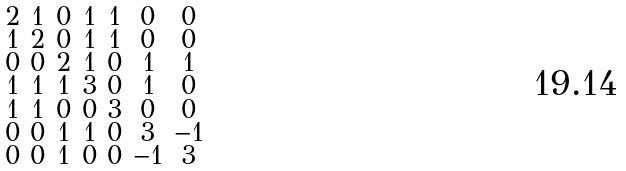Convert formula to latex. <formula><loc_0><loc_0><loc_500><loc_500>\begin{smallmatrix} 2 & 1 & 0 & 1 & 1 & 0 & 0 \\ 1 & 2 & 0 & 1 & 1 & 0 & 0 \\ 0 & 0 & 2 & 1 & 0 & 1 & 1 \\ 1 & 1 & 1 & 3 & 0 & 1 & 0 \\ 1 & 1 & 0 & 0 & 3 & 0 & 0 \\ 0 & 0 & 1 & 1 & 0 & 3 & - 1 \\ 0 & 0 & 1 & 0 & 0 & - 1 & 3 \end{smallmatrix}</formula> 